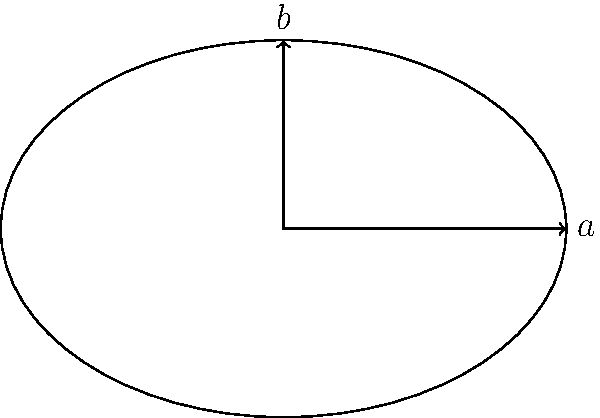As a historical fiction writer researching ancient Roman architecture, you come across plans for an elliptical amphitheater. The amphitheater's semi-major axis measures 60 meters, and its semi-minor axis is 40 meters. Calculate the area of this amphitheater's arena to the nearest square meter. To calculate the area of an elliptical amphitheater, we'll use the formula for the area of an ellipse:

$$A = \pi ab$$

Where:
$A$ = area
$a$ = semi-major axis
$b$ = semi-minor axis
$\pi$ ≈ 3.14159

Given:
$a = 60$ meters
$b = 40$ meters

Step 1: Substitute the values into the formula:
$$A = \pi (60)(40)$$

Step 2: Multiply the values inside the parentheses:
$$A = \pi (2400)$$

Step 3: Multiply by π:
$$A = 7539.82...$$

Step 4: Round to the nearest square meter:
$$A ≈ 7540 \text{ m}^2$$

This calculation provides the approximate area of the ancient Roman amphitheater's arena, which can be used to accurately describe the scale of the structure in your historical fiction novel.
Answer: 7540 m² 